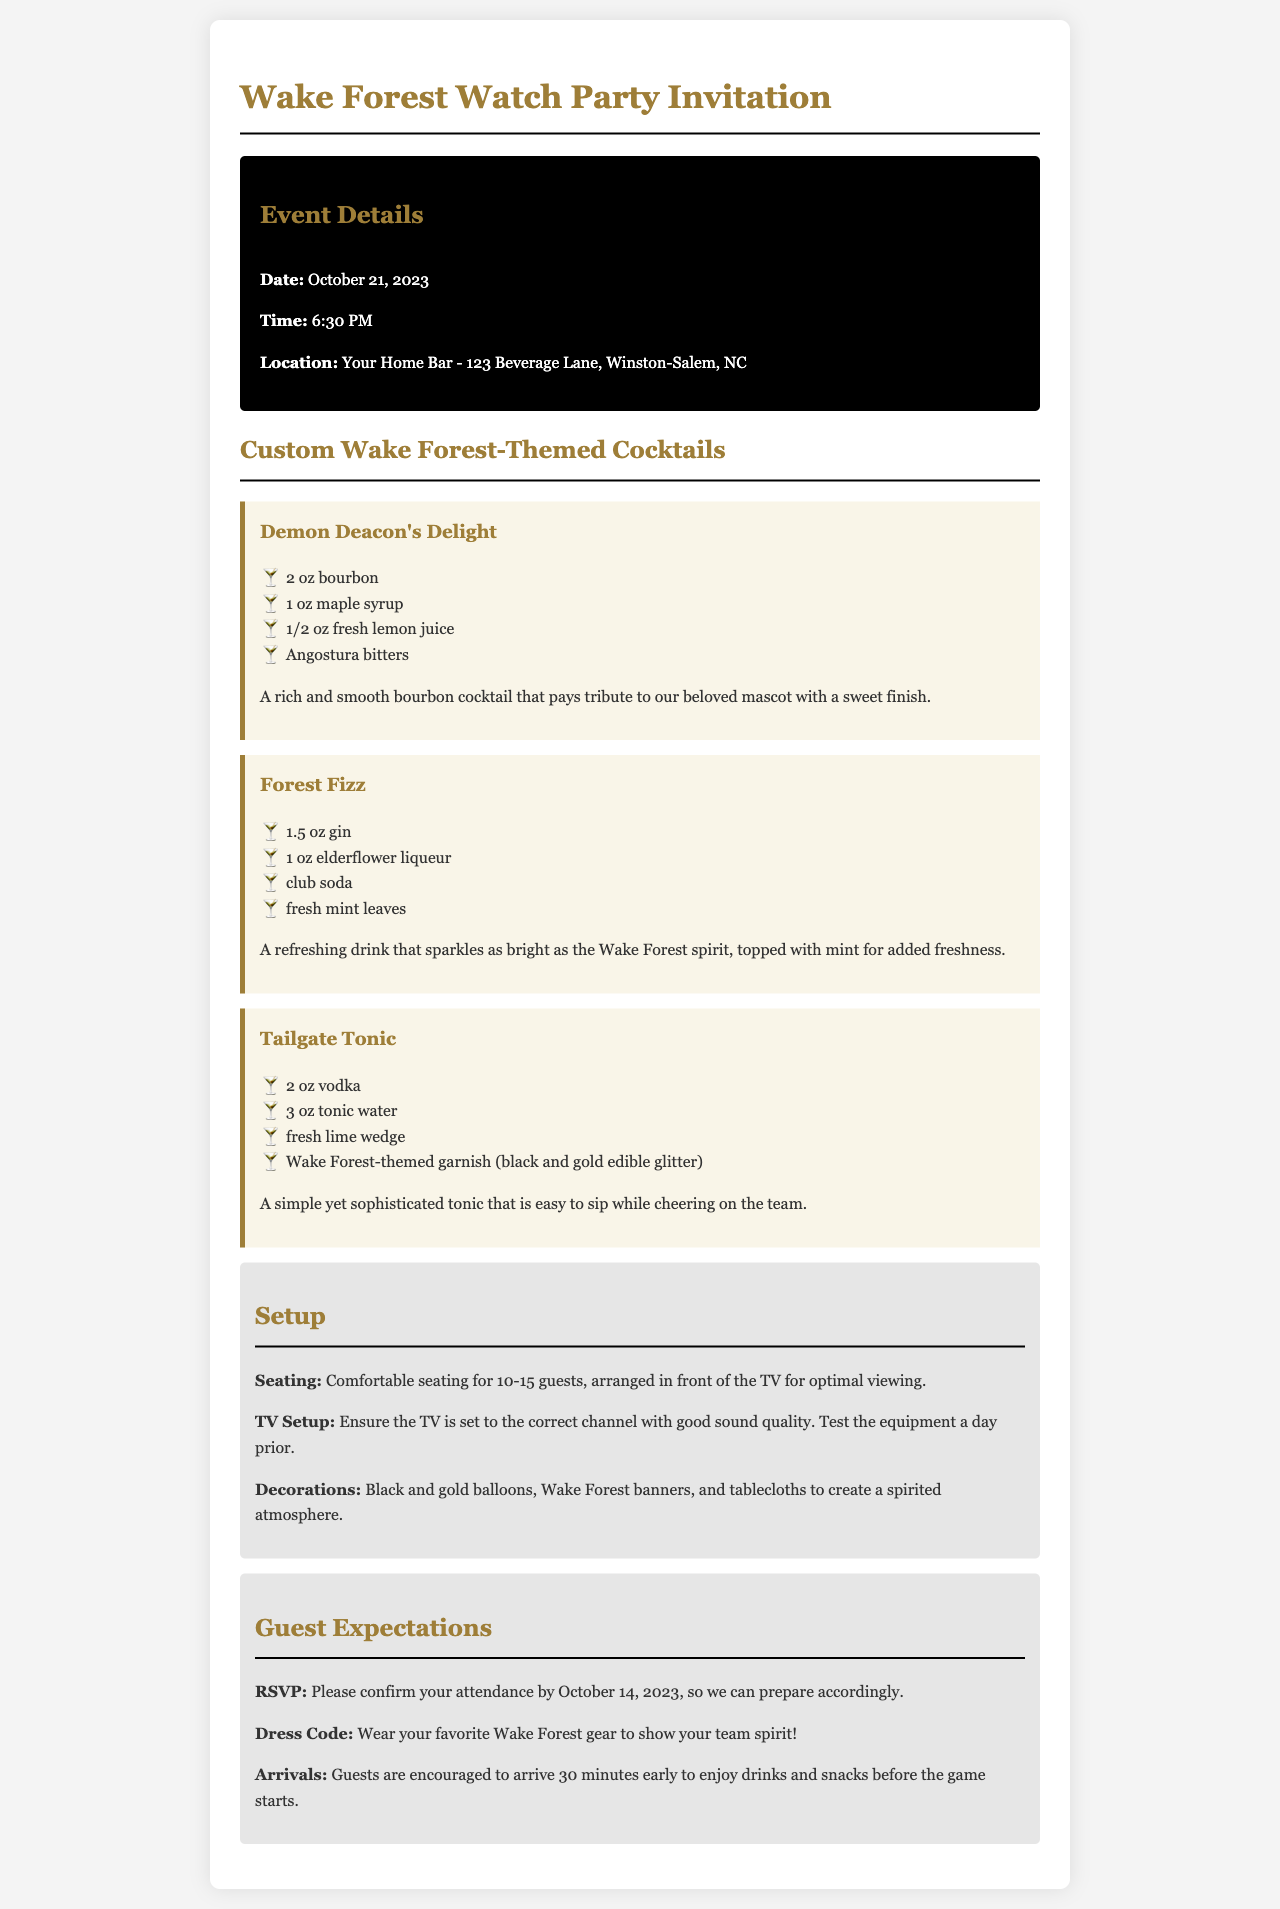What is the date of the event? The date of the event is specified in the document, which is October 21, 2023.
Answer: October 21, 2023 What time does the watch party start? The start time of the watch party is mentioned as 6:30 PM.
Answer: 6:30 PM Where is the location of the watch party? The location is given in the document as Your Home Bar - 123 Beverage Lane, Winston-Salem, NC.
Answer: Your Home Bar - 123 Beverage Lane, Winston-Salem, NC What cocktail includes elderflower liqueur? The drink that contains elderflower liqueur is specifically identified in the document as Forest Fizz.
Answer: Forest Fizz How many guests can be comfortably seated? The seating arrangement is detailed in the document to accommodate 10-15 guests comfortably.
Answer: 10-15 guests What is the dress code for the event? The document outlines that the dress code is to wear your favorite Wake Forest gear.
Answer: Wake Forest gear By when should guests confirm their attendance? The RSVP deadline for guest attendance is stated in the document as October 14, 2023.
Answer: October 14, 2023 What type of decorations are suggested for the event? The document suggests using black and gold balloons and Wake Forest banners as decorations.
Answer: Black and gold balloons, Wake Forest banners What is the wake forest-themed garnish in the Tailgate Tonic? The garnish specified in the Tailgate Tonic is black and gold edible glitter.
Answer: Black and gold edible glitter 